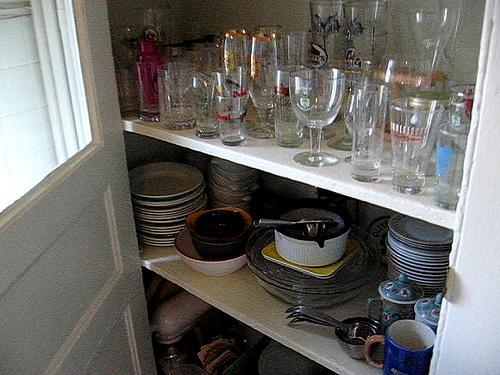Where are these items being stored?

Choices:
A) refrigerator
B) cabinet
C) shed
D) box cabinet 